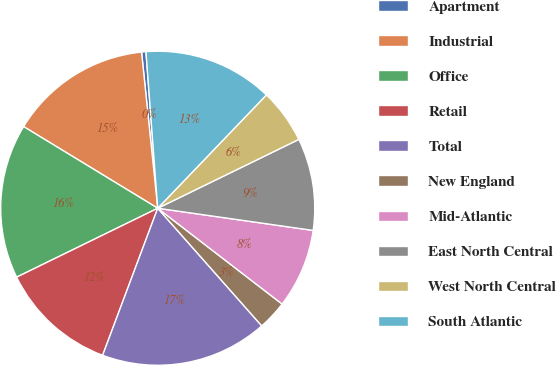Convert chart. <chart><loc_0><loc_0><loc_500><loc_500><pie_chart><fcel>Apartment<fcel>Industrial<fcel>Office<fcel>Retail<fcel>Total<fcel>New England<fcel>Mid-Atlantic<fcel>East North Central<fcel>West North Central<fcel>South Atlantic<nl><fcel>0.45%<fcel>14.65%<fcel>15.94%<fcel>12.06%<fcel>17.23%<fcel>3.03%<fcel>8.19%<fcel>9.48%<fcel>5.61%<fcel>13.36%<nl></chart> 